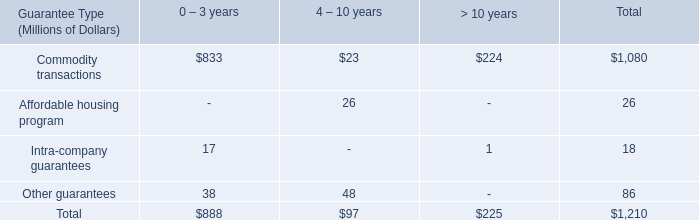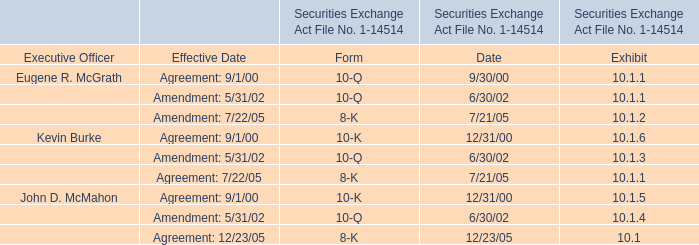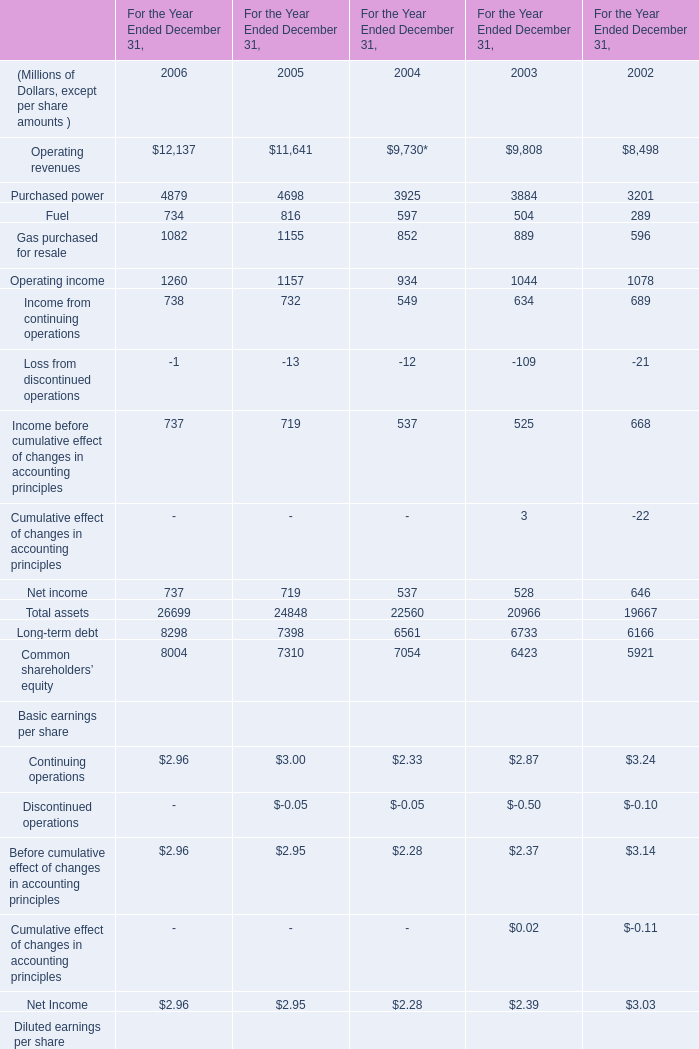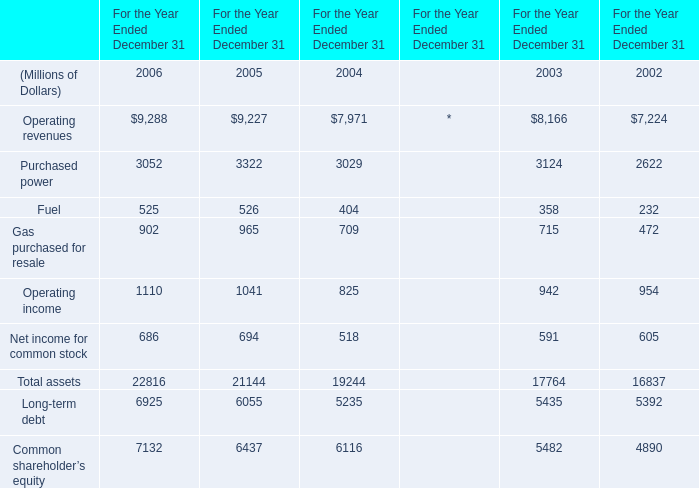assuming all options are exercised on 625 madison avenue , what year will the current agreement expire? 
Computations: ((2022 + 23) + 23)
Answer: 2068.0. 